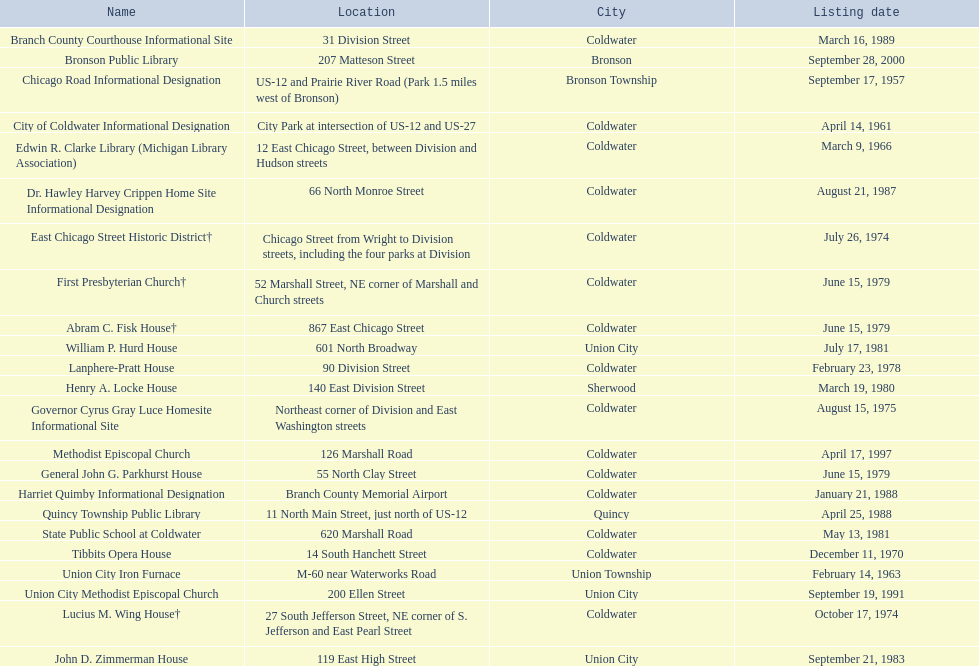In branch county, mi, what historic places are situated near or alongside a highway? Chicago Road Informational Designation, City of Coldwater Informational Designation, Quincy Township Public Library, Union City Iron Furnace. Of the historic places in branch county close to highways, which ones are near exclusively us highways? Chicago Road Informational Designation, City of Coldwater Informational Designation, Quincy Township Public Library. Which historical places in branch county are nearby only us highways and are not a building? Chicago Road Informational Designation, City of Coldwater Informational Designation. Which non-building historical places in branch county near a us highway is closest to bronson? Chicago Road Informational Designation. 